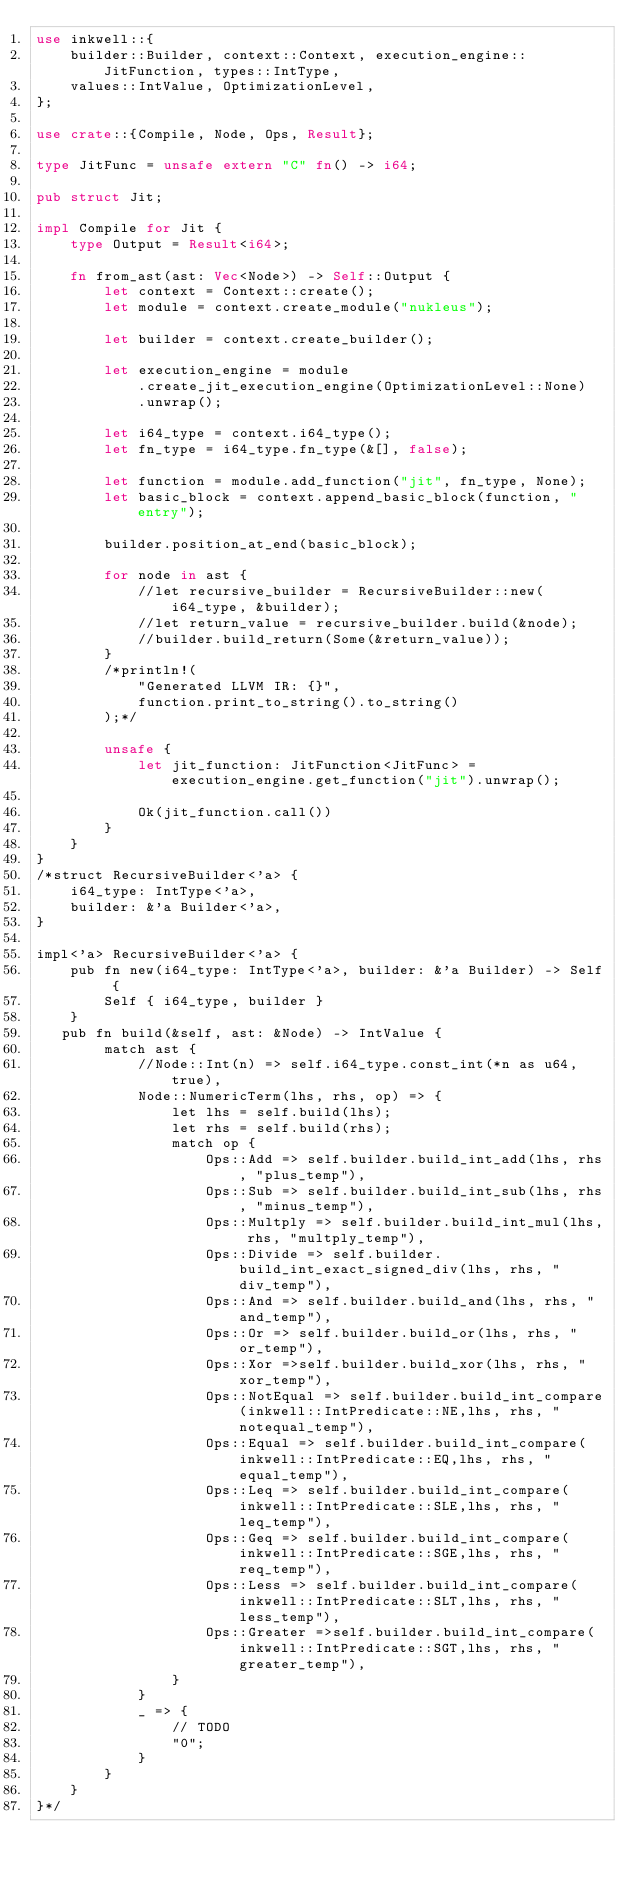Convert code to text. <code><loc_0><loc_0><loc_500><loc_500><_Rust_>use inkwell::{
    builder::Builder, context::Context, execution_engine::JitFunction, types::IntType,
    values::IntValue, OptimizationLevel,
};

use crate::{Compile, Node, Ops, Result};

type JitFunc = unsafe extern "C" fn() -> i64;

pub struct Jit;

impl Compile for Jit {
    type Output = Result<i64>;

    fn from_ast(ast: Vec<Node>) -> Self::Output {
        let context = Context::create();
        let module = context.create_module("nukleus");

        let builder = context.create_builder();

        let execution_engine = module
            .create_jit_execution_engine(OptimizationLevel::None)
            .unwrap();

        let i64_type = context.i64_type();
        let fn_type = i64_type.fn_type(&[], false);

        let function = module.add_function("jit", fn_type, None);
        let basic_block = context.append_basic_block(function, "entry");

        builder.position_at_end(basic_block);

        for node in ast {
            //let recursive_builder = RecursiveBuilder::new(i64_type, &builder);
            //let return_value = recursive_builder.build(&node);
            //builder.build_return(Some(&return_value));
        }
        /*println!(
            "Generated LLVM IR: {}",
            function.print_to_string().to_string()
        );*/

        unsafe {
            let jit_function: JitFunction<JitFunc> = execution_engine.get_function("jit").unwrap();

            Ok(jit_function.call())
        }
    }
}
/*struct RecursiveBuilder<'a> {
    i64_type: IntType<'a>,
    builder: &'a Builder<'a>,
}

impl<'a> RecursiveBuilder<'a> {
    pub fn new(i64_type: IntType<'a>, builder: &'a Builder) -> Self {
        Self { i64_type, builder }
    }
   pub fn build(&self, ast: &Node) -> IntValue {
        match ast {
            //Node::Int(n) => self.i64_type.const_int(*n as u64, true),
            Node::NumericTerm(lhs, rhs, op) => {
                let lhs = self.build(lhs);
                let rhs = self.build(rhs);
                match op {
                    Ops::Add => self.builder.build_int_add(lhs, rhs, "plus_temp"),
                    Ops::Sub => self.builder.build_int_sub(lhs, rhs, "minus_temp"),
                    Ops::Multply => self.builder.build_int_mul(lhs, rhs, "multply_temp"),
                    Ops::Divide => self.builder.build_int_exact_signed_div(lhs, rhs, "div_temp"),
                    Ops::And => self.builder.build_and(lhs, rhs, "and_temp"),
                    Ops::Or => self.builder.build_or(lhs, rhs, "or_temp"),
                    Ops::Xor =>self.builder.build_xor(lhs, rhs, "xor_temp"),
                    Ops::NotEqual => self.builder.build_int_compare(inkwell::IntPredicate::NE,lhs, rhs, "notequal_temp"),
                    Ops::Equal => self.builder.build_int_compare(inkwell::IntPredicate::EQ,lhs, rhs, "equal_temp"),
                    Ops::Leq => self.builder.build_int_compare(inkwell::IntPredicate::SLE,lhs, rhs, "leq_temp"),
                    Ops::Geq => self.builder.build_int_compare(inkwell::IntPredicate::SGE,lhs, rhs, "req_temp"),
                    Ops::Less => self.builder.build_int_compare(inkwell::IntPredicate::SLT,lhs, rhs, "less_temp"),
                    Ops::Greater =>self.builder.build_int_compare(inkwell::IntPredicate::SGT,lhs, rhs, "greater_temp"),
                }
            }
            _ => {
                // TODO
                "0";
            }
        }
    }
}*/
</code> 